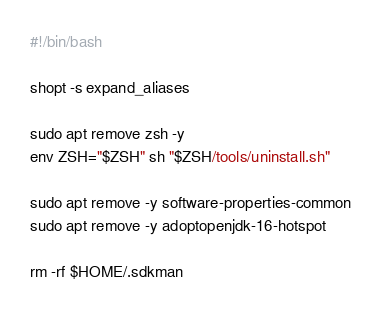<code> <loc_0><loc_0><loc_500><loc_500><_Bash_>#!/bin/bash

shopt -s expand_aliases

sudo apt remove zsh -y
env ZSH="$ZSH" sh "$ZSH/tools/uninstall.sh"

sudo apt remove -y software-properties-common
sudo apt remove -y adoptopenjdk-16-hotspot

rm -rf $HOME/.sdkman</code> 